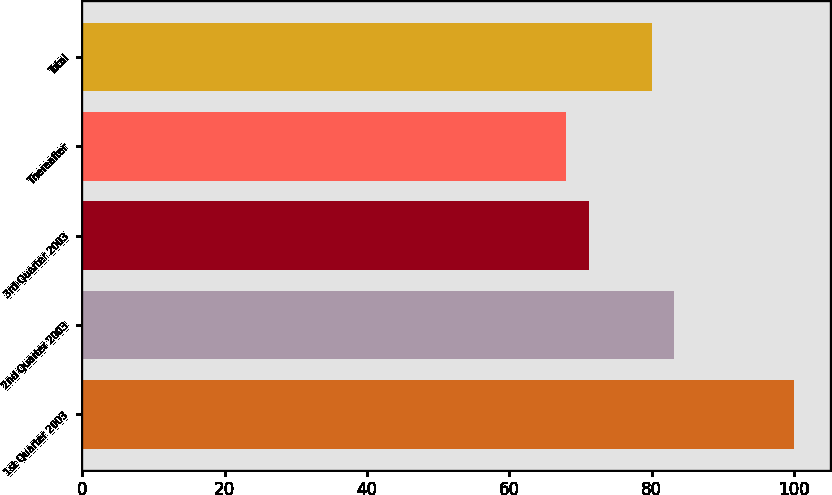Convert chart. <chart><loc_0><loc_0><loc_500><loc_500><bar_chart><fcel>1st Quarter 2003<fcel>2nd Quarter 2003<fcel>3rd Quarter 2003<fcel>Thereafter<fcel>Total<nl><fcel>100<fcel>83.2<fcel>71.2<fcel>68<fcel>80<nl></chart> 